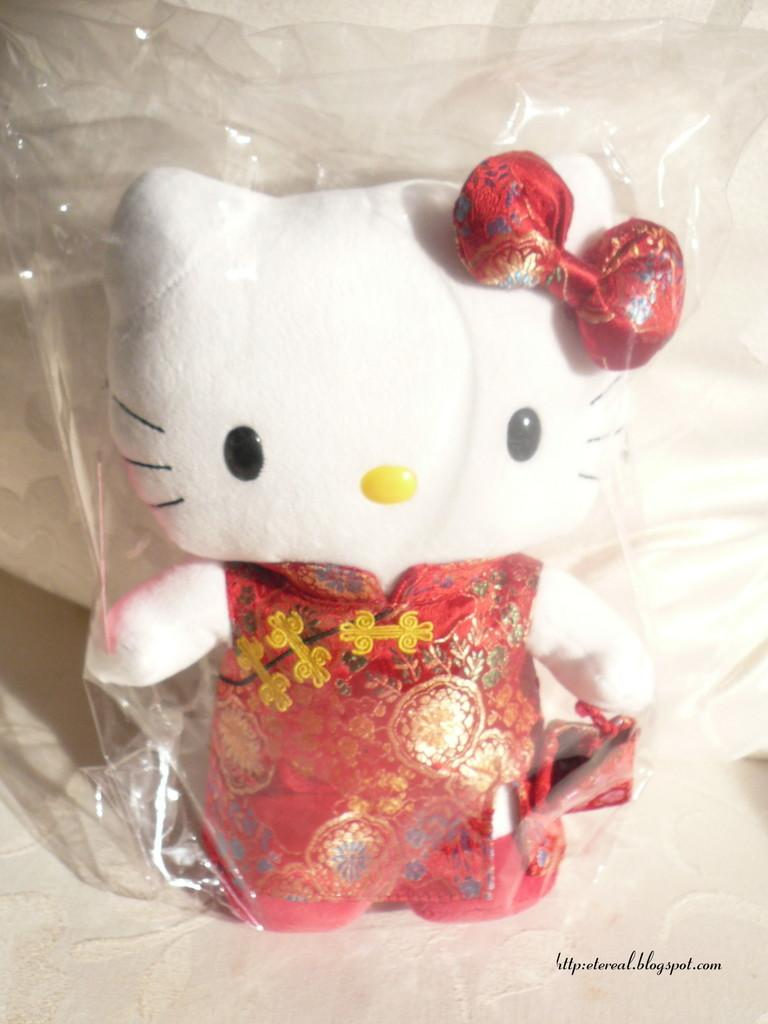What type of toy is visible in the image? There is a Hello Kitty toy in the image. How is the Hello Kitty toy being displayed? The Hello Kitty toy is in a transparent cover. Can you describe any additional features of the image? There is a watermark in the bottom right corner of the image. What type of legal advice can be obtained from the Hello Kitty toy in the image? The Hello Kitty toy is not a lawyer and cannot provide legal advice. 